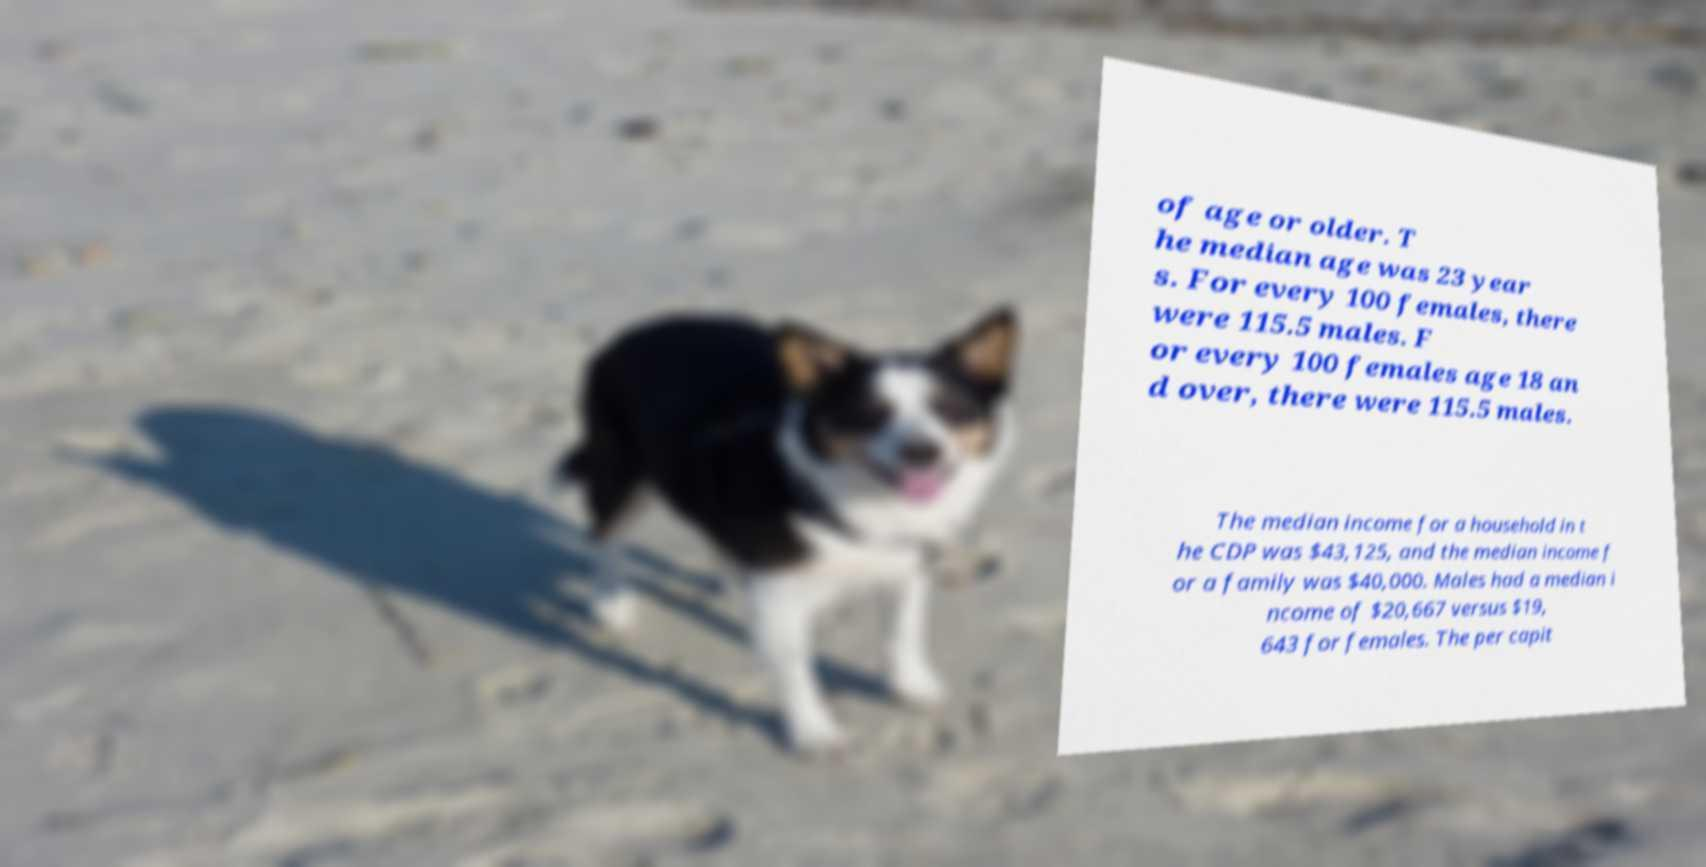I need the written content from this picture converted into text. Can you do that? of age or older. T he median age was 23 year s. For every 100 females, there were 115.5 males. F or every 100 females age 18 an d over, there were 115.5 males. The median income for a household in t he CDP was $43,125, and the median income f or a family was $40,000. Males had a median i ncome of $20,667 versus $19, 643 for females. The per capit 